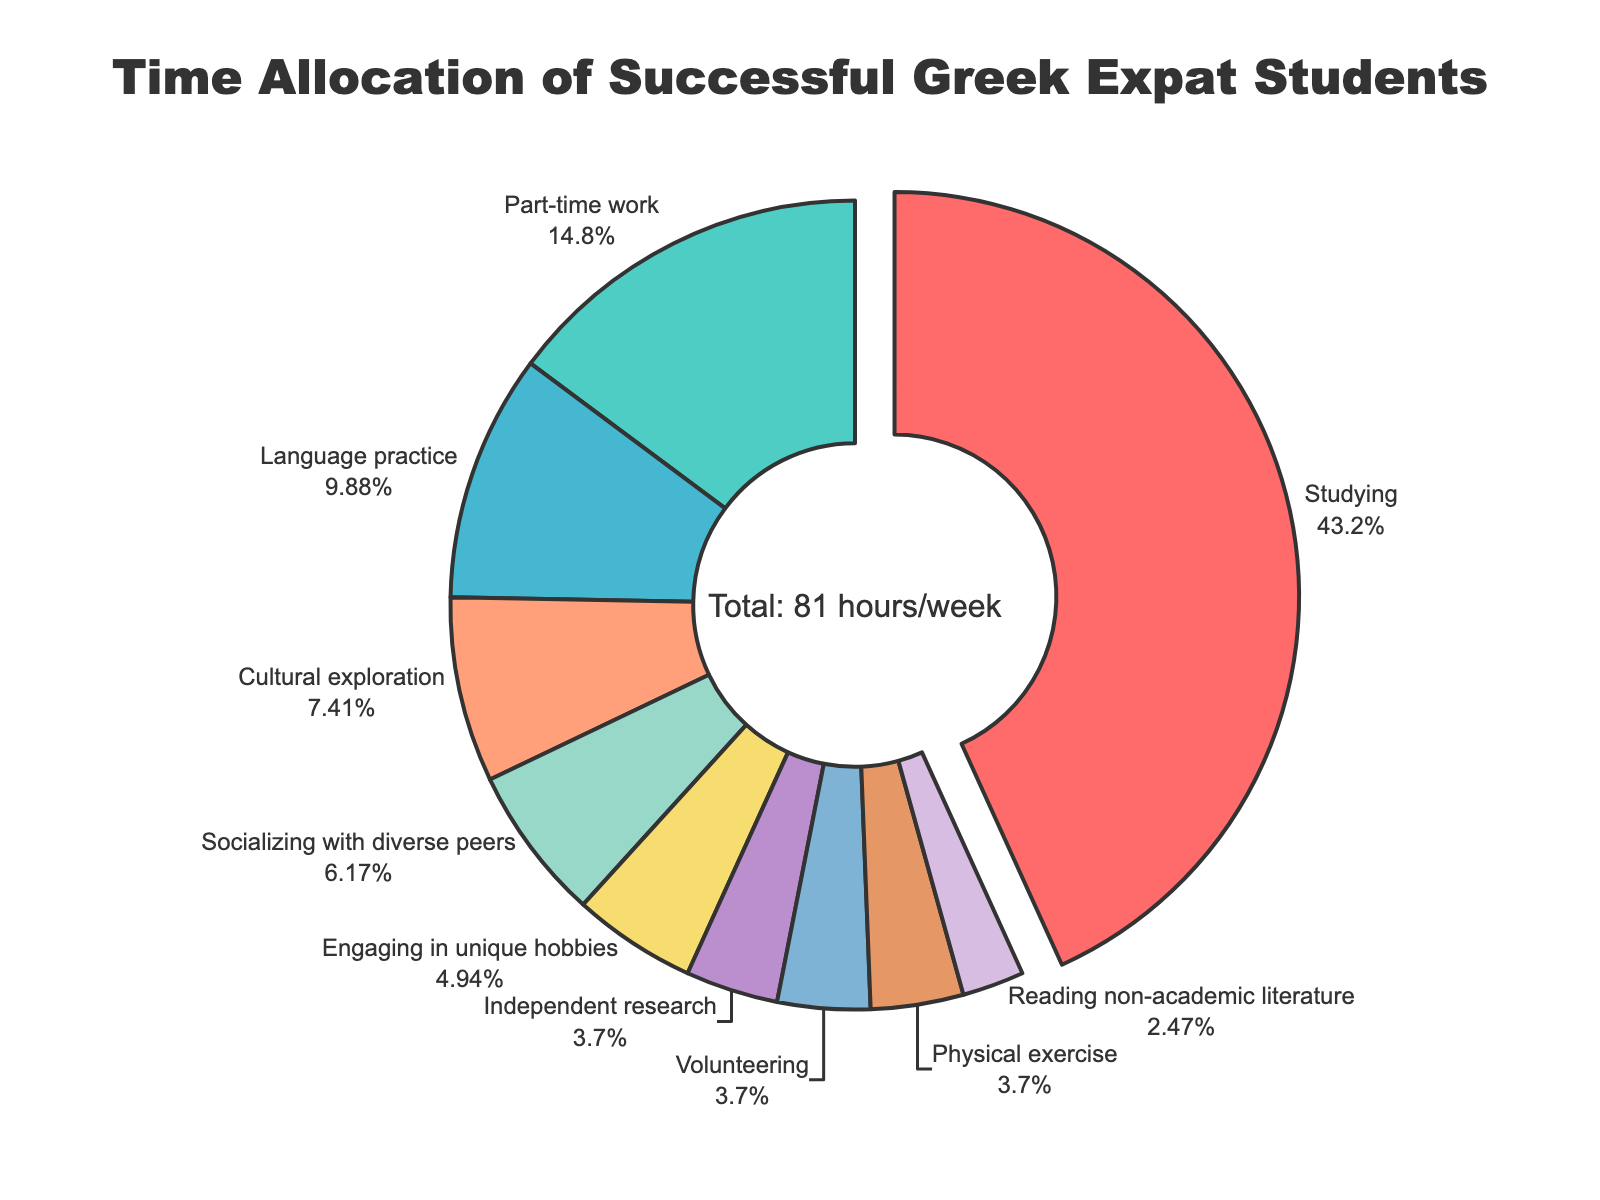What activity takes up the largest percentage of time? The segment representing "Studying" is pulled out slightly in the pie chart, which indicates it's the largest. According to the textinfo on the chart, "Studying" makes up 39.8% of the total time allocation.
Answer: Studying What is the combined percentage of time spent on part-time work and language practice? Referring to the pie chart, part-time work and language practice segments occupy 13.6% and 9.1% of the time, respectively. The combined percentage is 13.6% + 9.1% = 22.7%.
Answer: 22.7% How much more time is spent socializing with diverse peers compared to volunteering? According to the pie chart, socializing with diverse peers takes 5 hours and volunteering takes 3 hours. The difference is 5 - 3 = 2 hours.
Answer: 2 hours Which activity takes a smaller percentage of time: engaging in unique hobbies or physical exercise? The pie chart shows that engaging in unique hobbies takes 4 hours, and physical exercise takes 3 hours. Thus, physical exercise occupies a smaller percentage.
Answer: Physical exercise What is the percentage of time spent on socializing with diverse peers compared to the total weekly hours? Socializing with diverse peers takes 5 hours. The total weekly hours across all activities is 81 hours. The percentage is (5/81) * 100 ≈ 6.2%.
Answer: 6.2% What is the average number of hours spent per week on independent research, volunteering, and physical exercise? The hours per week for independent research, volunteering, and physical exercise are 3, 3, and 3, respectively. The average is (3 + 3 + 3) / 3 = 3.
Answer: 3 What is the total number of hours spent on activities other than studying and part-time work? The total hours for all activities are 81. Studying and part-time work take 35 and 12 hours, respectively, summing to 47 hours. The remaining hours are 81 - 47 = 34 hours.
Answer: 34 hours Which activity takes up the smallest percentage of time, and what is this percentage? According to the chart, reading non-academic literature is allocated 2 hours, which is the smallest compared to other activities. The percentage is (2/81) * 100 ≈ 2.5%.
Answer: Reading non-academic literature, 2.5% 